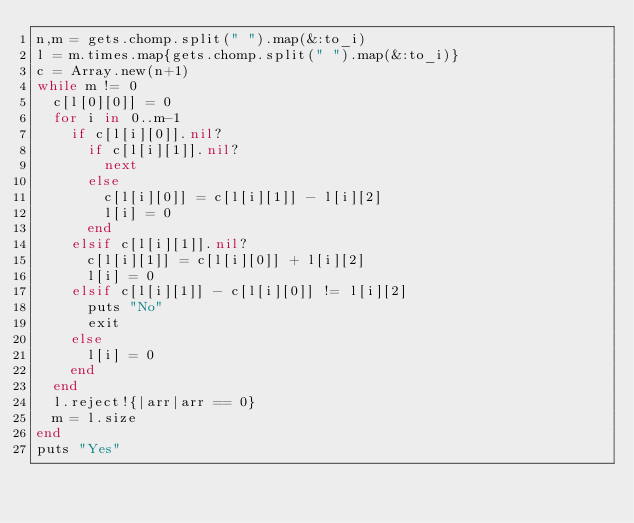Convert code to text. <code><loc_0><loc_0><loc_500><loc_500><_Ruby_>n,m = gets.chomp.split(" ").map(&:to_i)
l = m.times.map{gets.chomp.split(" ").map(&:to_i)}
c = Array.new(n+1)
while m != 0
  c[l[0][0]] = 0
  for i in 0..m-1
    if c[l[i][0]].nil?
      if c[l[i][1]].nil?
        next
      else
        c[l[i][0]] = c[l[i][1]] - l[i][2]
        l[i] = 0
      end
    elsif c[l[i][1]].nil?
      c[l[i][1]] = c[l[i][0]] + l[i][2]
      l[i] = 0
    elsif c[l[i][1]] - c[l[i][0]] != l[i][2]
      puts "No"
      exit
    else
      l[i] = 0
    end
  end
  l.reject!{|arr|arr == 0}
  m = l.size
end
puts "Yes"</code> 